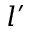Convert formula to latex. <formula><loc_0><loc_0><loc_500><loc_500>l ^ { \prime }</formula> 